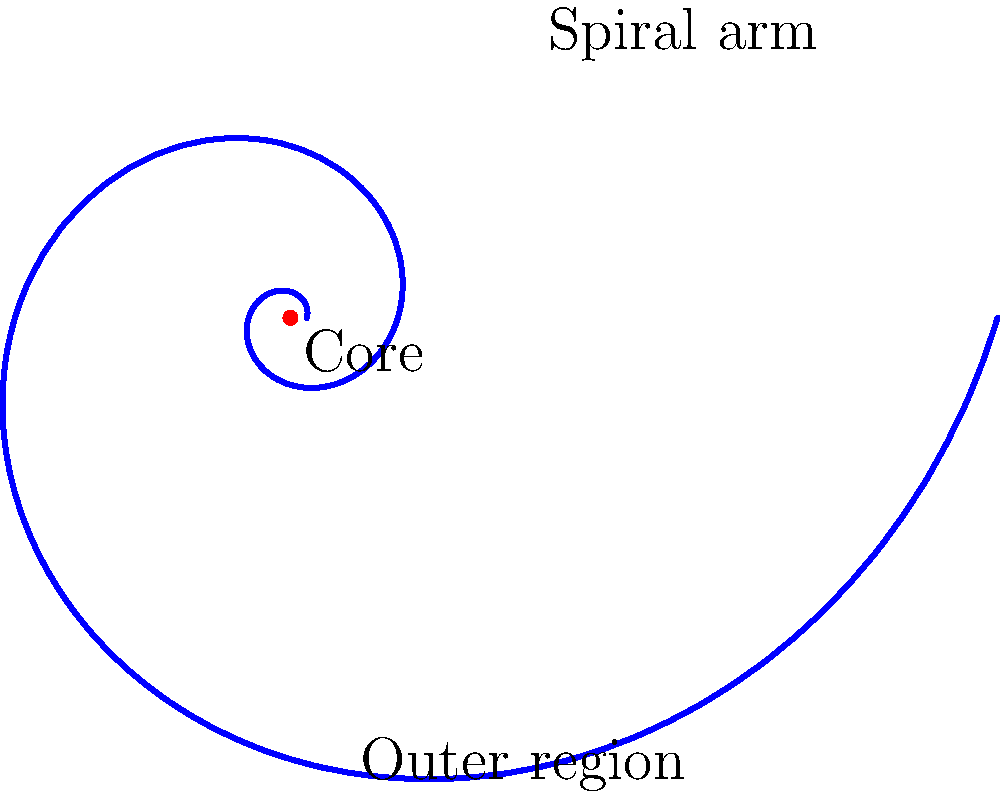In the context of Danny Boyle's visually striking filmmaking style, imagine you're designing a shot that zooms out from the center of a spiral galaxy. Which part of the galaxy structure, represented in the spiral graphic, would you focus on to create a sense of expansive scale similar to the vast landscapes often featured in Boyle's films? To answer this question, let's break down the structure of a spiral galaxy and relate it to Danny Boyle's cinematographic style:

1. Core: The center of the galaxy, represented by the red dot in the graphic. This is the densest part of the galaxy, often featuring a supermassive black hole.

2. Spiral arms: The curved structures emanating from the core, shown as the blue spiral in the graphic. These contain most of the galaxy's visible matter, including stars, gas, and dust.

3. Outer region: The area beyond the spiral arms, represented by the space around the outermost part of the spiral in the graphic.

Danny Boyle is known for his visually striking and often expansive shots that create a sense of scale and wonder. To replicate this in the context of a galaxy:

- Starting with the core would provide a sense of origin but wouldn't capture the vast scale.
- The spiral arms would show the intricate structure and movement of the galaxy, but might not fully convey its enormous size.
- The outer region, extending far beyond the visible spiral arms, would best capture the immense scale and vastness of the galaxy.

By focusing on the outer region as the camera zooms out, you would create a sense of expansive scale similar to Boyle's use of vast landscapes. This approach would visually communicate the enormous size of the galaxy, evoking a sense of awe and wonder that aligns with Boyle's cinematic style.
Answer: Outer region 